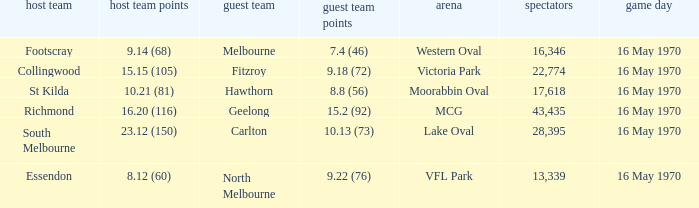What did the away team score when the home team was south melbourne? 10.13 (73). 